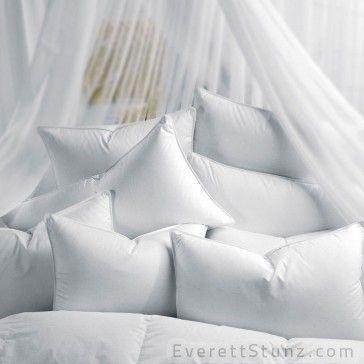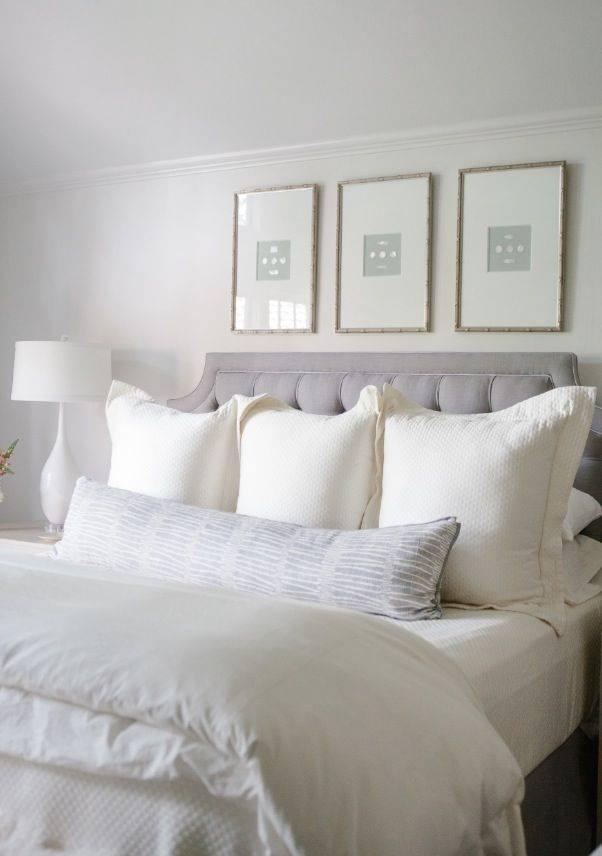The first image is the image on the left, the second image is the image on the right. Analyze the images presented: Is the assertion "An image shows pillows in front of a non-tufted headboard." valid? Answer yes or no. No. 